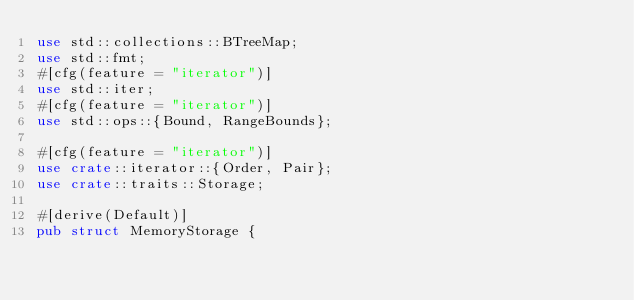Convert code to text. <code><loc_0><loc_0><loc_500><loc_500><_Rust_>use std::collections::BTreeMap;
use std::fmt;
#[cfg(feature = "iterator")]
use std::iter;
#[cfg(feature = "iterator")]
use std::ops::{Bound, RangeBounds};

#[cfg(feature = "iterator")]
use crate::iterator::{Order, Pair};
use crate::traits::Storage;

#[derive(Default)]
pub struct MemoryStorage {</code> 